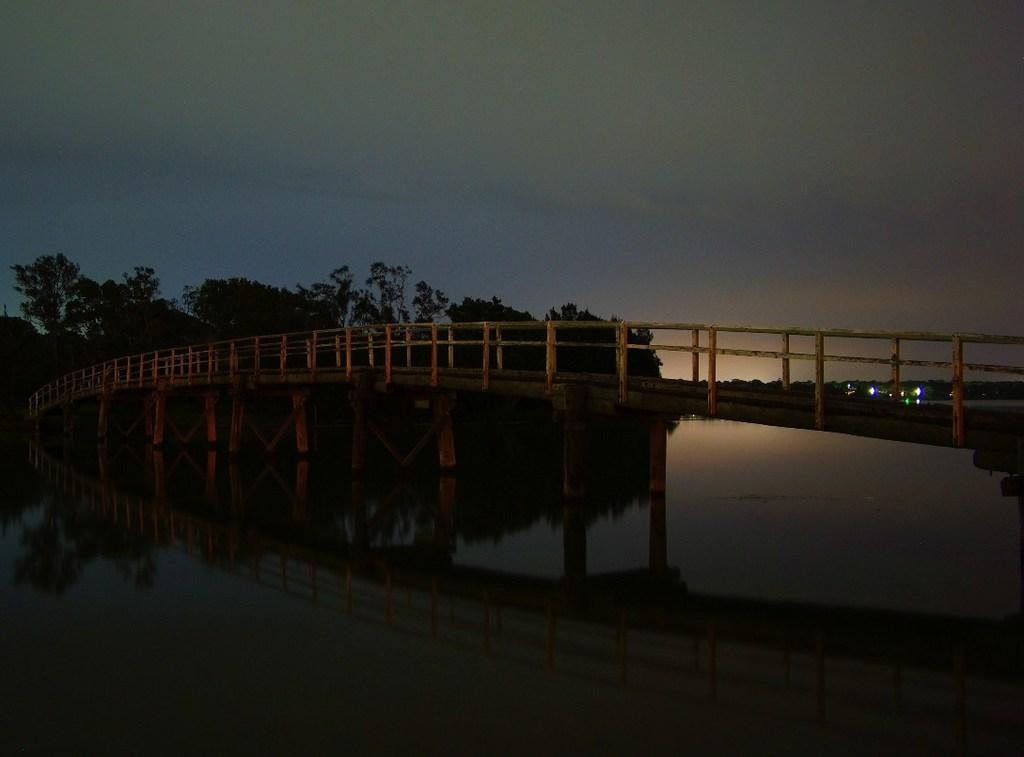What is in the foreground of the image? There is water in the foreground of the image. What structure can be seen in the middle of the image? There is a bridge in the middle of the image. What type of vegetation is visible in the background of the image? There are trees in the background of the image. What can be seen on the right side of the image? There are lights on the right side of the image. What is visible in the background of the image besides the trees? The sky is visible in the background of the image. Can you describe the sky in the image? The sky is visible in the background of the image, and there is a cloud visible in the sky. What type of trousers are hanging on the bridge in the image? There are no trousers present in the image; it features a bridge over water with trees in the background. Can you describe the fly that is buzzing around the cloud in the image? There is no fly present in the image; it features a bridge over water with trees in the background and a cloud visible in the sky. 